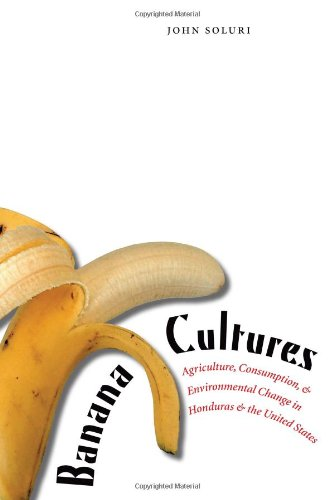Can you tell me more about the environmental aspects discussed in this book? The book discusses how banana cultivation has led to significant environmental changes, including deforestation and pesticide use, affecting local ecosystems and global health. 